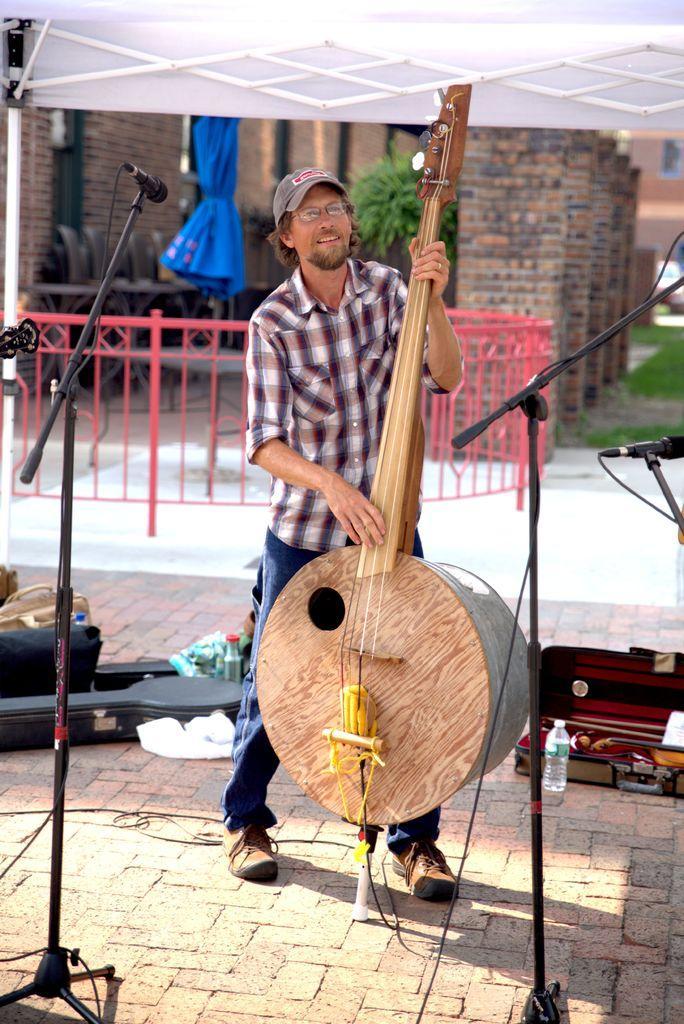Can you describe this image briefly? A person is standing and playing a musical instrument. There are microphones. There are bottles and other objects at the back. There is a red fence, blue closed umbrella and buildings at the back. 